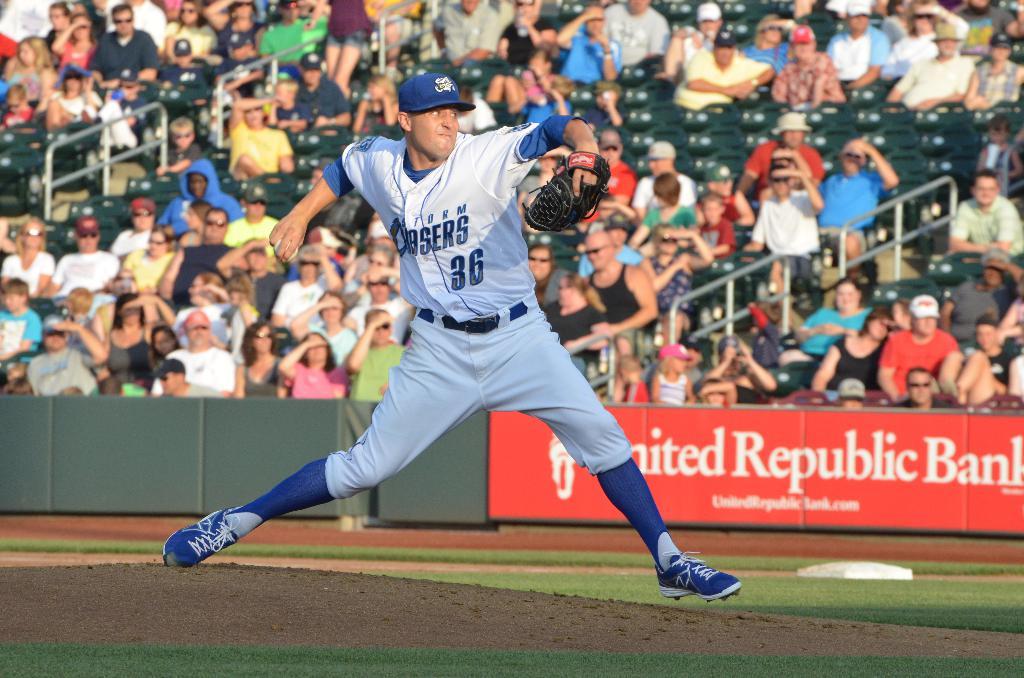In the background, who is the sponsor in red?
Give a very brief answer. United republic bank. What is the pitchers number?
Your answer should be compact. 36. 